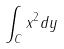<formula> <loc_0><loc_0><loc_500><loc_500>\int _ { C } x ^ { 2 } d y</formula> 